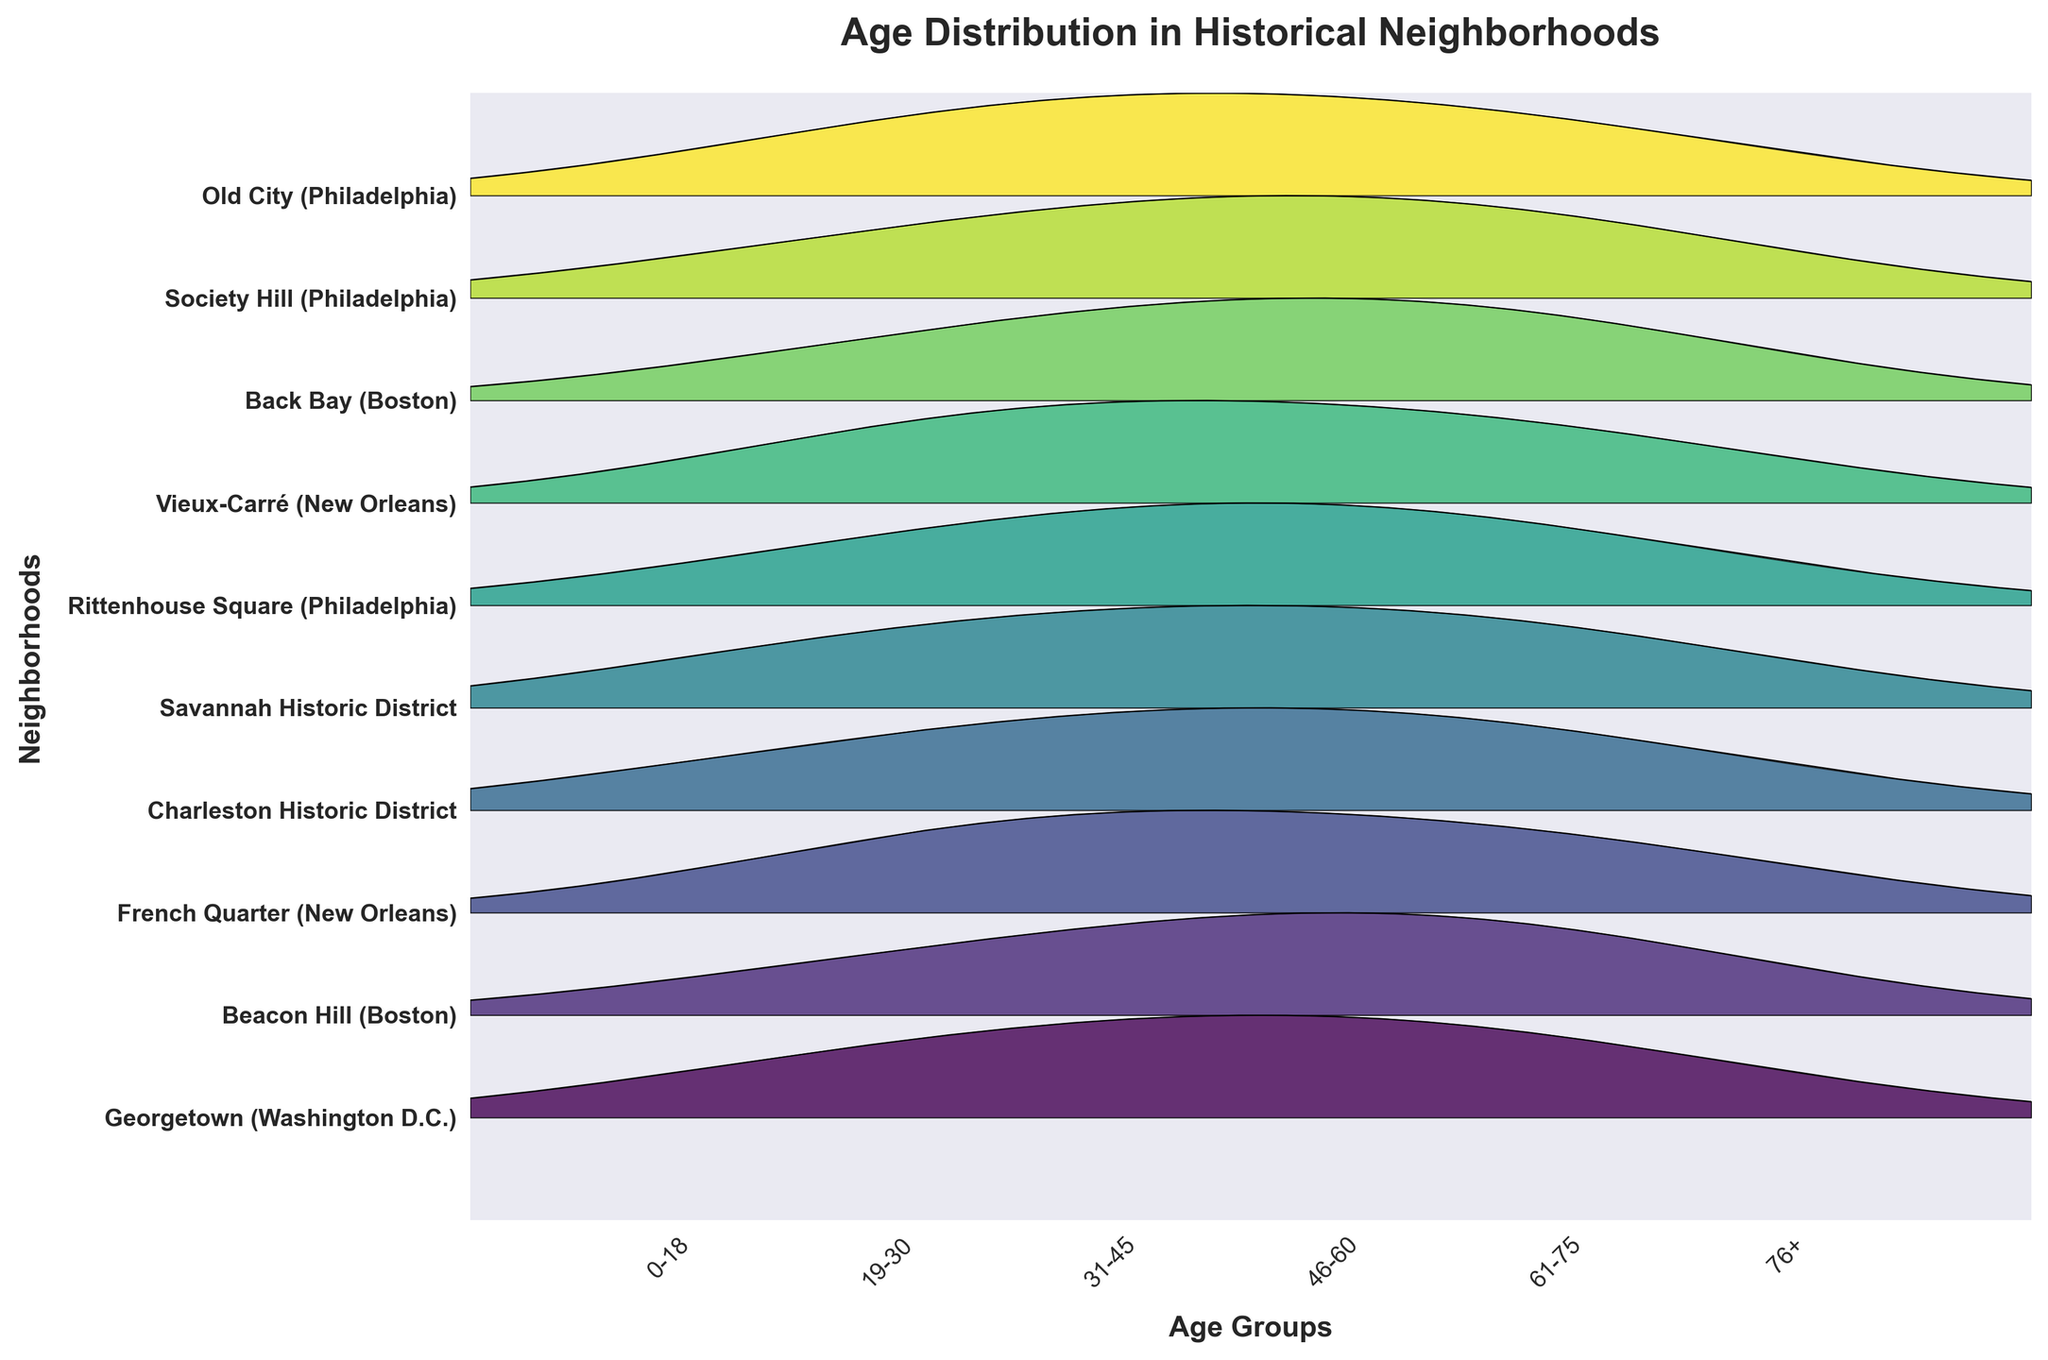What is the title of the figure? The title of the figure is usually the biggest text at the top. Here, clearly visible at the top, it reads 'Age Distribution in Historical Neighborhoods'.
Answer: Age Distribution in Historical Neighborhoods Which neighborhood shows the highest concentration of young adults (19-30)? To find this, look at the peaks of the ridgeline plots for the 19-30 age group. The highest peak in this group appears for ‘Vieux-Carré (New Orleans)’.
Answer: Vieux-Carré (New Orleans) How many age groups are being compared in the plot? The x-axis shows the age groups being compared. There are six age groups labeled: '0-18', '19-30', '31-45', '46-60', '61-75', and '76+'.
Answer: 6 Which neighborhood has a relatively low population of older adults (76+)? Look for the neighborhood whose plot has the smallest area or the lowest peak in the '76+' age group. The lowest peak in this category seems to be ‘Georgetown (Washington D.C.)’.
Answer: Georgetown (Washington D.C.) What is the overall trend in the age distribution for Beacon Hill (Boston)? Follow the ridge line of Beacon Hill (Boston). It starts low in the '0-18' age group, increases towards '19-30', and reaches a peak in '46-60', then decreases again.
Answer: Low to high to low Which neighborhood has a higher concentration of adults aged 46-60: Rittenhouse Square (Philadelphia) or Society Hill (Philadelphia)? Compare the peaks of the ridgelines for both neighborhoods in the '46-60' age group. Rittenhouse Square (Philadelphia) has a slightly higher peak.
Answer: Rittenhouse Square (Philadelphia) Among the neighborhoods listed, which has the most evenly distributed population across age groups? An evenly distributed population would have similar peak heights across the age groups. Charleston Historic District appears to have a relatively balanced distribution of heights among the age groups.
Answer: Charleston Historic District Are there more neighborhoods with higher populations of young adults (19-30) or middle-aged adults (31-45)? Compare the number of neighborhoods where the plots have higher peaks in the '19-30' group versus the '31-45' group. More neighborhoods ('Georgetown', 'French Quarter', 'Vieux-Carré') have higher peaks in the '31-45' age group.
Answer: Middle-aged adults (31-45) Which age group shows the least variation in the ridgelines across different neighborhoods? Age variation can be assessed by looking at the uniformity of the peak sizes in each age group across the ridgelines. The '76+' age group shows very little variation, with most neighborhoods having similar small peaks.
Answer: 76+ 